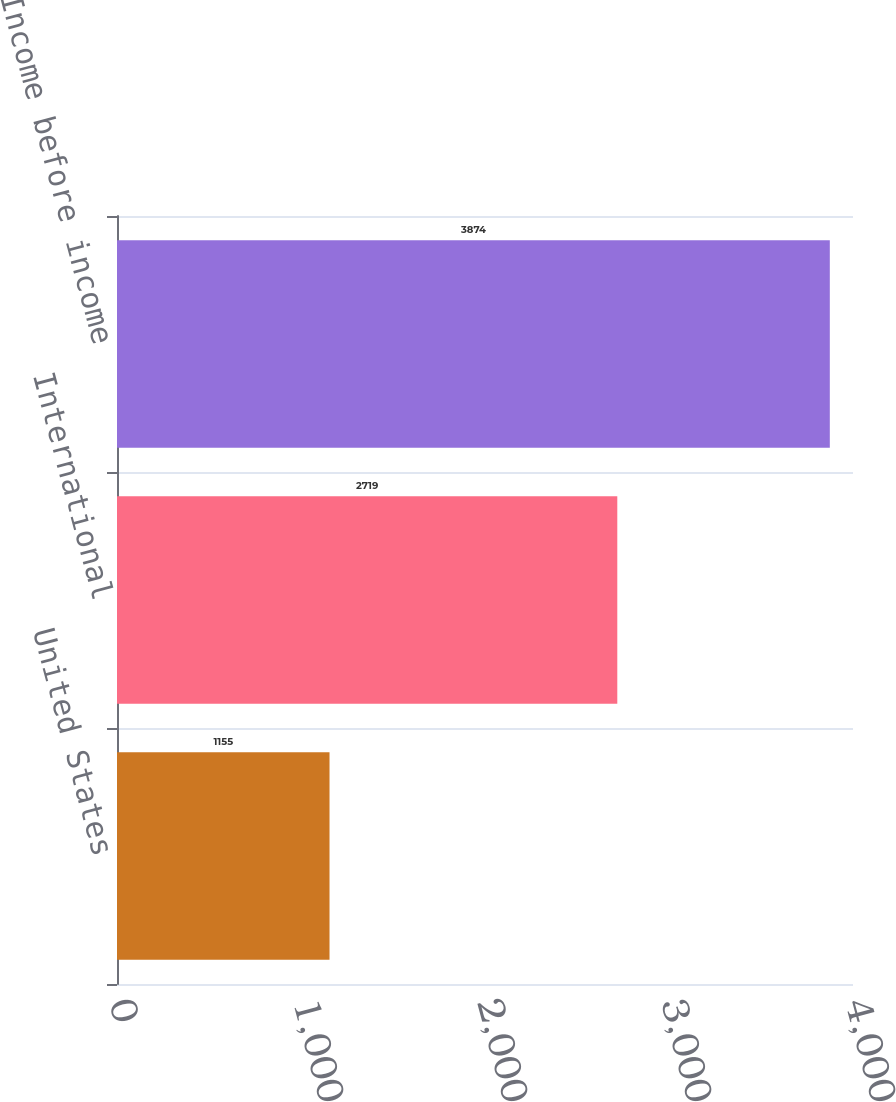<chart> <loc_0><loc_0><loc_500><loc_500><bar_chart><fcel>United States<fcel>International<fcel>Total Income before income<nl><fcel>1155<fcel>2719<fcel>3874<nl></chart> 